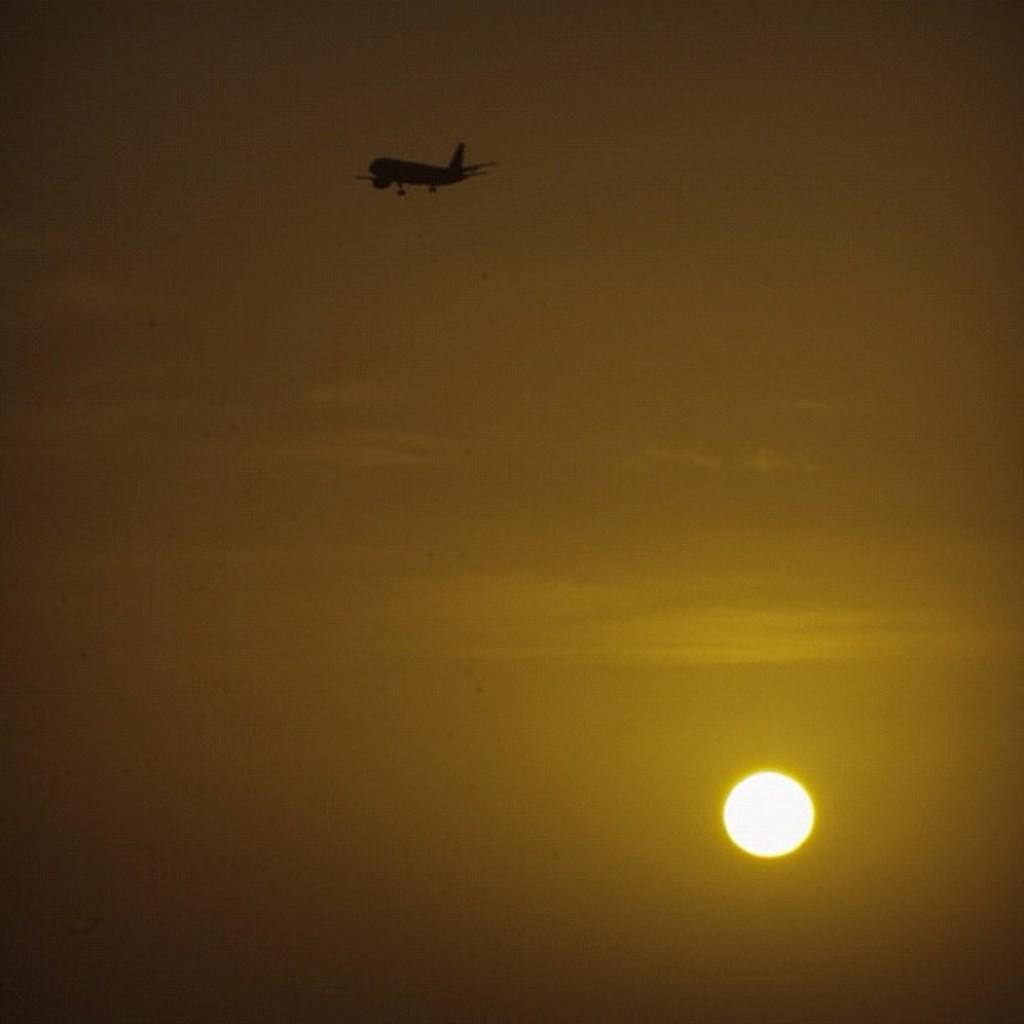What is the main subject located at the top side of the image? There is an aircraft at the top side of the image. What can be seen on the right side of the image? There appears to be a representation of the moon on the right side of the image. Can you tell me how much salt is present on the island in the image? There is no island or salt present in the image; it features an aircraft and a representation of the moon. 